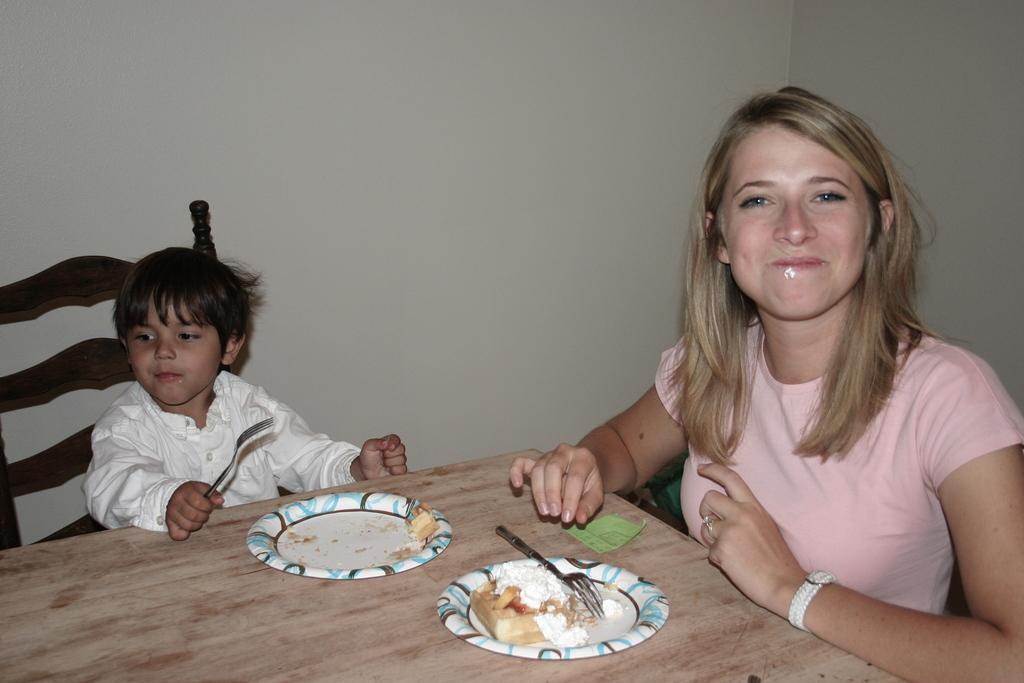Please provide a concise description of this image. In this image I can see a woman and a baby sitting on the table and having cake and I can see plates in front of them on a wooden table I can see a chair over here and the background is a wall. 